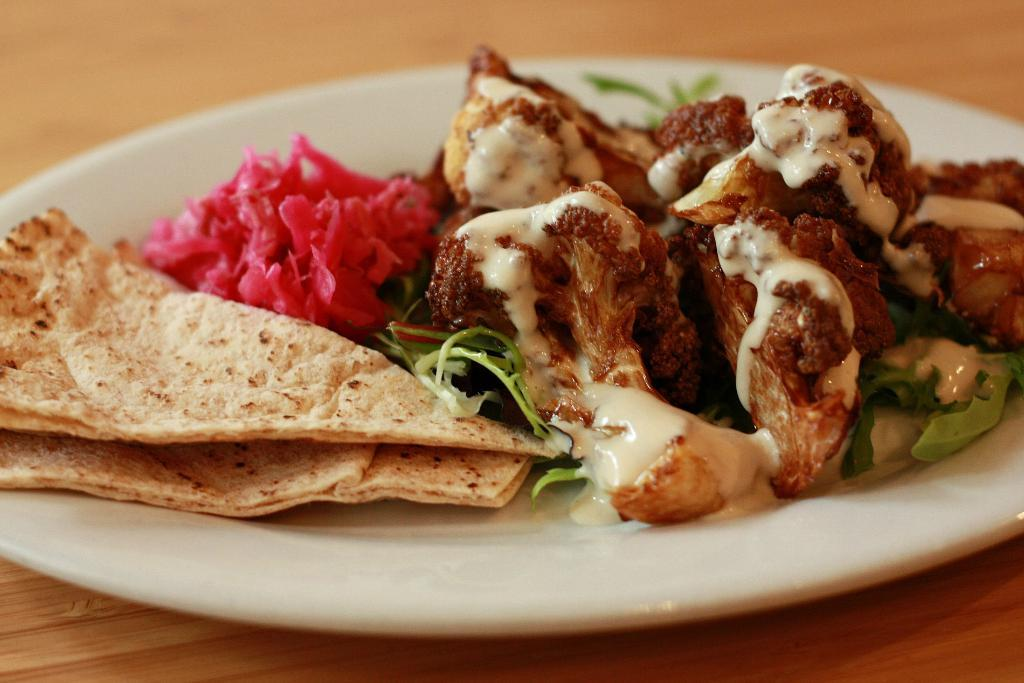What is the main subject of the image? There is a food item on a plate in the image. Can you describe the surface on which the plate is placed? The plate is placed on a wooden table. What type of theory is being discussed in the image? There is no discussion or mention of any theory in the image; it primarily features a food item on a plate and a wooden table. 